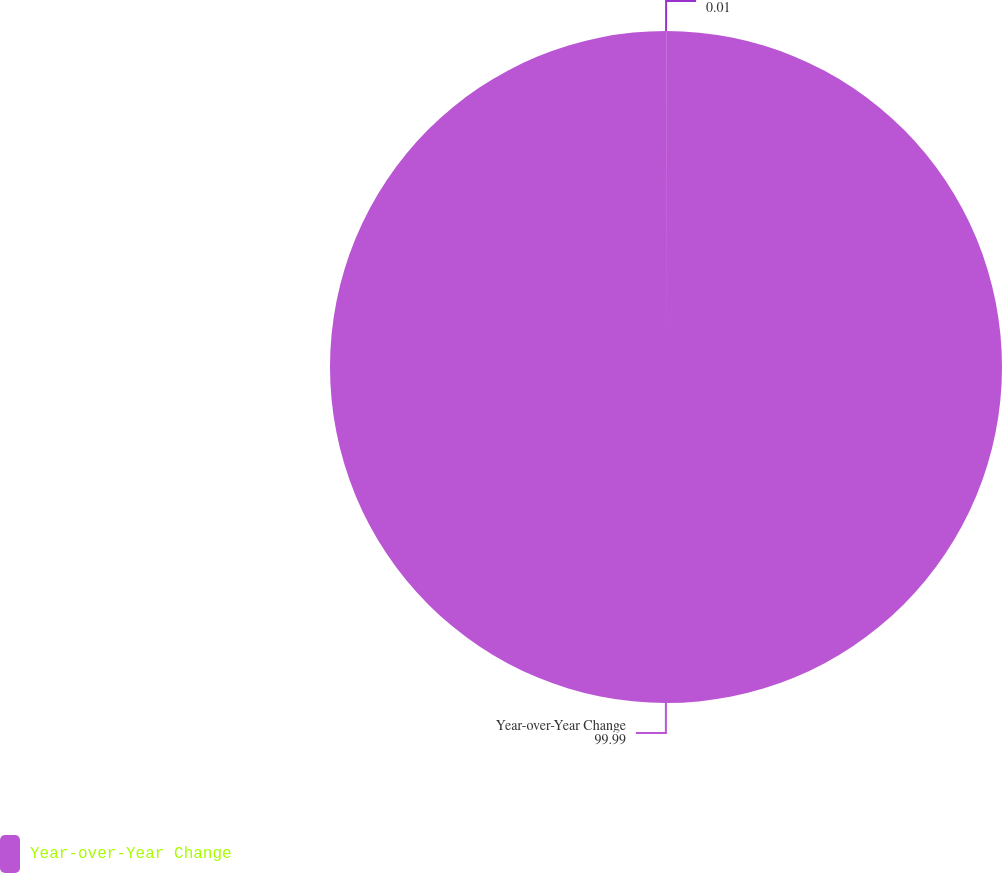<chart> <loc_0><loc_0><loc_500><loc_500><pie_chart><ecel><fcel>Year-over-Year Change<nl><fcel>0.01%<fcel>99.99%<nl></chart> 